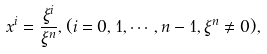Convert formula to latex. <formula><loc_0><loc_0><loc_500><loc_500>x ^ { i } = \frac { \xi ^ { i } } { \xi ^ { n } } , ( i = 0 , 1 , \cdots , n - 1 , \xi ^ { n } \not = 0 ) ,</formula> 